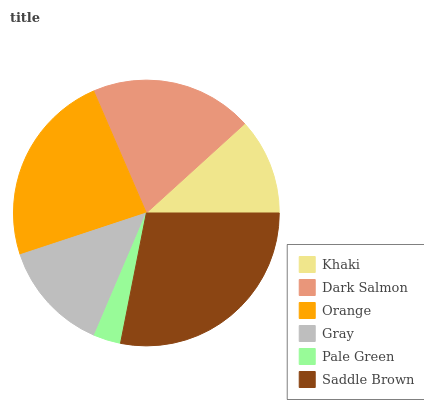Is Pale Green the minimum?
Answer yes or no. Yes. Is Saddle Brown the maximum?
Answer yes or no. Yes. Is Dark Salmon the minimum?
Answer yes or no. No. Is Dark Salmon the maximum?
Answer yes or no. No. Is Dark Salmon greater than Khaki?
Answer yes or no. Yes. Is Khaki less than Dark Salmon?
Answer yes or no. Yes. Is Khaki greater than Dark Salmon?
Answer yes or no. No. Is Dark Salmon less than Khaki?
Answer yes or no. No. Is Dark Salmon the high median?
Answer yes or no. Yes. Is Gray the low median?
Answer yes or no. Yes. Is Gray the high median?
Answer yes or no. No. Is Khaki the low median?
Answer yes or no. No. 